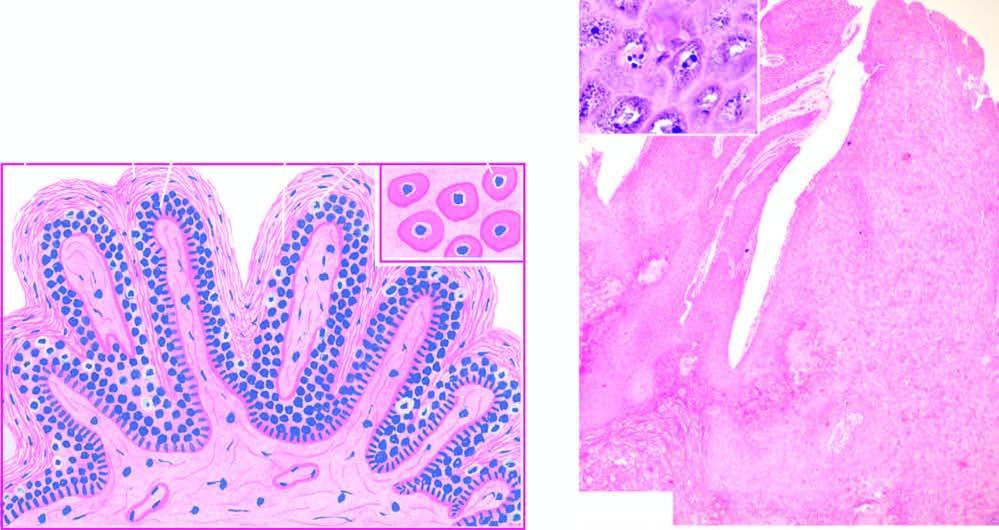does inset show koilocytes and virus-infected keratinocytes containing prominent keratohyaline granules?
Answer the question using a single word or phrase. Yes 